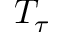<formula> <loc_0><loc_0><loc_500><loc_500>T _ { \tau }</formula> 